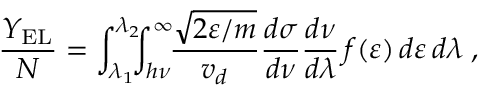Convert formula to latex. <formula><loc_0><loc_0><loc_500><loc_500>\frac { Y _ { E L } } { N } = \int _ { \lambda _ { 1 } } ^ { \lambda _ { 2 } } \, \int _ { h \nu } ^ { \infty } \, \frac { \sqrt { 2 \varepsilon / m } } { v _ { d } } \frac { d \sigma } { d \nu } \frac { d \nu } { d \lambda } \, f ( \varepsilon ) \, d \varepsilon \, d \lambda \, ,</formula> 